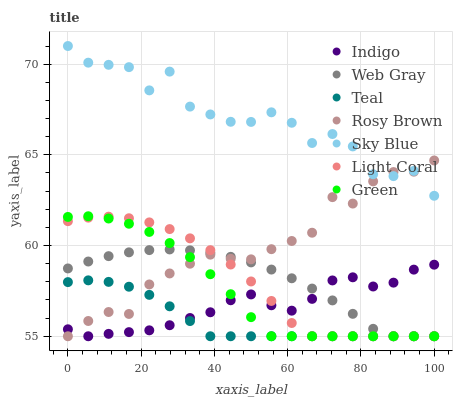Does Teal have the minimum area under the curve?
Answer yes or no. Yes. Does Sky Blue have the maximum area under the curve?
Answer yes or no. Yes. Does Indigo have the minimum area under the curve?
Answer yes or no. No. Does Indigo have the maximum area under the curve?
Answer yes or no. No. Is Teal the smoothest?
Answer yes or no. Yes. Is Sky Blue the roughest?
Answer yes or no. Yes. Is Indigo the smoothest?
Answer yes or no. No. Is Indigo the roughest?
Answer yes or no. No. Does Web Gray have the lowest value?
Answer yes or no. Yes. Does Sky Blue have the lowest value?
Answer yes or no. No. Does Sky Blue have the highest value?
Answer yes or no. Yes. Does Indigo have the highest value?
Answer yes or no. No. Is Light Coral less than Sky Blue?
Answer yes or no. Yes. Is Sky Blue greater than Light Coral?
Answer yes or no. Yes. Does Indigo intersect Light Coral?
Answer yes or no. Yes. Is Indigo less than Light Coral?
Answer yes or no. No. Is Indigo greater than Light Coral?
Answer yes or no. No. Does Light Coral intersect Sky Blue?
Answer yes or no. No. 